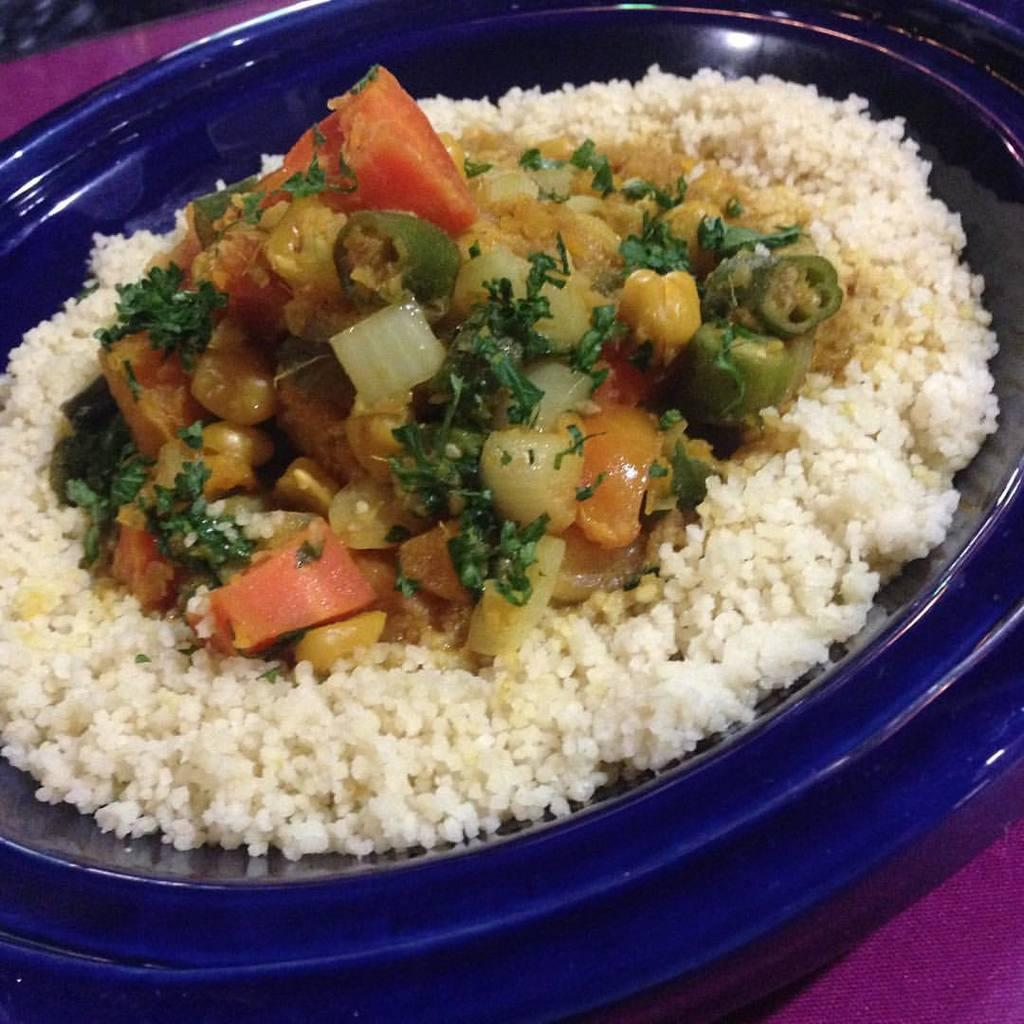What is on the plate that is visible in the image? There is food on a plate in the image. Where is the plate located in the image? The plate is on a table at the bottom of the image. How does the food on the plate make the lawyer feel in the image? There is no lawyer present in the image, so it is not possible to determine how the food on the plate might make them feel. 